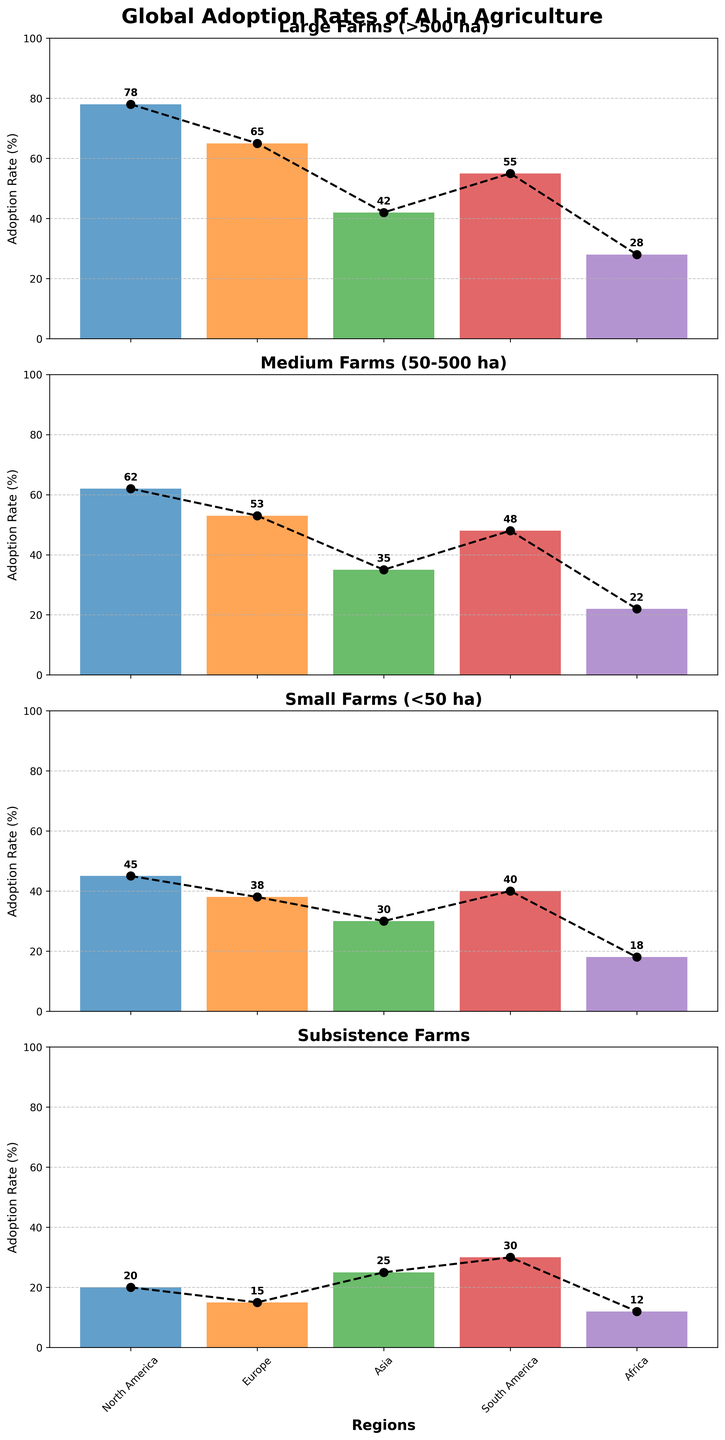Which region has the highest adoption rate for large farms? The plot for large farms shows the highest bar for North America.
Answer: North America How does the adoption rate of AI compare between large farms and subsistence farms in Europe? The bar for large farms in Europe is at 65%, while the bar for subsistence farms in Europe is at 15%.
Answer: 65% for large farms and 15% for subsistence farms Which region has the lowest adoption rate for small farms? The plot for small farms shows the lowest bar for Africa.
Answer: Africa What is the average adoption rate of AI in South America across all farm sizes? For South America, add up the values (55 + 48 + 40 + 30) and divide by the number of farm sizes (4), which gives (173 / 4).
Answer: 43.25% Compare the adoption rates for medium farms in North America and Asia. What is the difference? The plot for medium farms shows North America at 62% and Asia at 35%. Subtract Asia's rate from North America's rate (62 - 35).
Answer: 27% Which farm size shows the smallest variation in adoption rates across different regions? Compare the height differences of bars across regions for each farm size. Subsistence farms show relatively small differences compared to others.
Answer: Subsistence farms Which farm size in North America has the lowest adoption rate and what is its rate? Compare the bars for North America across different farm sizes. Subsistence farms have the lowest rate at 20%.
Answer: Subsistence farms, 20% What region has the highest adoption rate for subsistence farms? The plot for subsistence farms shows the highest bar for South America.
Answer: South America How does the adoption rate of AI in Africa compare for large farms and small farms? For Africa, large farms have an adoption rate of 28% and small farms have an adoption rate of 18%.
Answer: 28% for large farms and 18% for small farms 